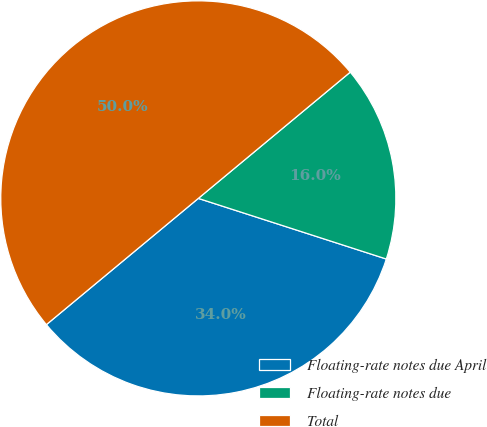Convert chart to OTSL. <chart><loc_0><loc_0><loc_500><loc_500><pie_chart><fcel>Floating-rate notes due April<fcel>Floating-rate notes due<fcel>Total<nl><fcel>34.0%<fcel>16.0%<fcel>50.0%<nl></chart> 